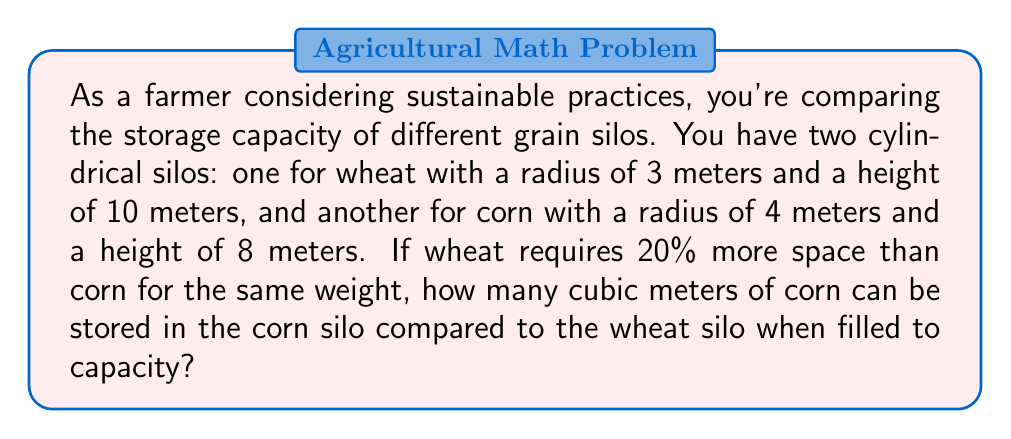Can you answer this question? Let's approach this step-by-step:

1) First, we need to calculate the volumes of both silos using the formula for the volume of a cylinder:
   $$V = \pi r^2 h$$
   where $r$ is the radius and $h$ is the height.

2) For the wheat silo:
   $$V_{wheat} = \pi (3\text{ m})^2 (10\text{ m}) = 90\pi \text{ m}^3$$

3) For the corn silo:
   $$V_{corn} = \pi (4\text{ m})^2 (8\text{ m}) = 128\pi \text{ m}^3$$

4) Now, we need to consider that wheat requires 20% more space than corn for the same weight. This means that the volume of wheat is 1.2 times the volume of corn for the same weight.

5) To compare the corn capacity of the corn silo to the wheat silo, we need to convert the wheat silo's capacity to its corn equivalent:
   $$V_{wheat\_in\_corn} = 90\pi \text{ m}^3 \times \frac{1}{1.2} = 75\pi \text{ m}^3$$

6) Now we can compare the corn capacities:
   $$\text{Difference} = V_{corn} - V_{wheat\_in\_corn} = 128\pi \text{ m}^3 - 75\pi \text{ m}^3 = 53\pi \text{ m}^3$$

7) To get the final answer, we calculate:
   $$53\pi \approx 166.50 \text{ m}^3$$

Therefore, the corn silo can store approximately 166.50 cubic meters more corn than the wheat silo when both are filled to capacity.
Answer: 166.50 m³ 